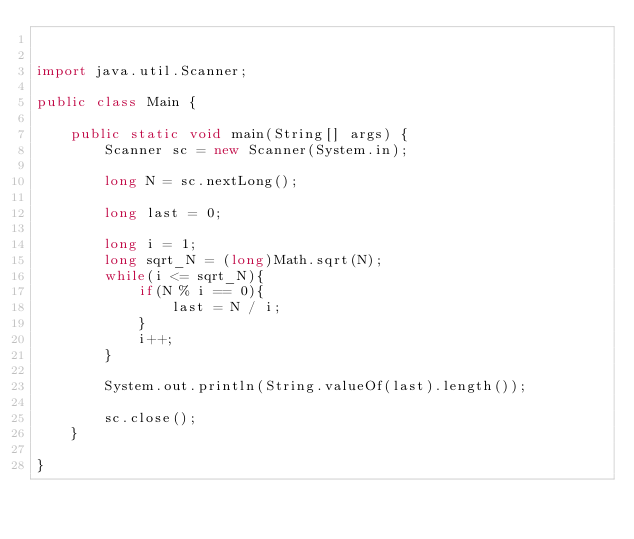Convert code to text. <code><loc_0><loc_0><loc_500><loc_500><_Java_>

import java.util.Scanner;

public class Main {

	public static void main(String[] args) {
		Scanner sc = new Scanner(System.in);

		long N = sc.nextLong();

		long last = 0;

		long i = 1;
		long sqrt_N = (long)Math.sqrt(N);
		while(i <= sqrt_N){
			if(N % i == 0){
				last = N / i;
			}
			i++;
		}

		System.out.println(String.valueOf(last).length());

		sc.close();
	}

}
</code> 